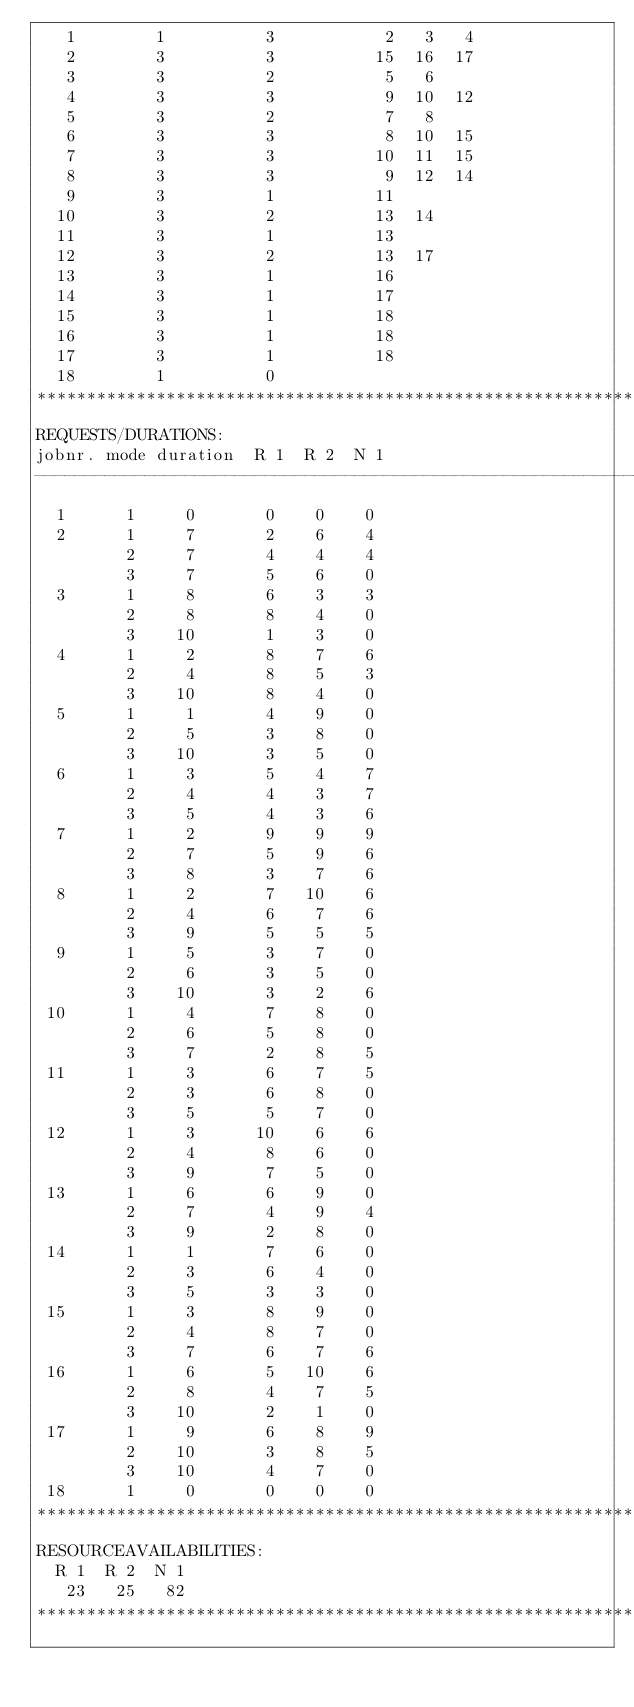<code> <loc_0><loc_0><loc_500><loc_500><_ObjectiveC_>   1        1          3           2   3   4
   2        3          3          15  16  17
   3        3          2           5   6
   4        3          3           9  10  12
   5        3          2           7   8
   6        3          3           8  10  15
   7        3          3          10  11  15
   8        3          3           9  12  14
   9        3          1          11
  10        3          2          13  14
  11        3          1          13
  12        3          2          13  17
  13        3          1          16
  14        3          1          17
  15        3          1          18
  16        3          1          18
  17        3          1          18
  18        1          0        
************************************************************************
REQUESTS/DURATIONS:
jobnr. mode duration  R 1  R 2  N 1
------------------------------------------------------------------------
  1      1     0       0    0    0
  2      1     7       2    6    4
         2     7       4    4    4
         3     7       5    6    0
  3      1     8       6    3    3
         2     8       8    4    0
         3    10       1    3    0
  4      1     2       8    7    6
         2     4       8    5    3
         3    10       8    4    0
  5      1     1       4    9    0
         2     5       3    8    0
         3    10       3    5    0
  6      1     3       5    4    7
         2     4       4    3    7
         3     5       4    3    6
  7      1     2       9    9    9
         2     7       5    9    6
         3     8       3    7    6
  8      1     2       7   10    6
         2     4       6    7    6
         3     9       5    5    5
  9      1     5       3    7    0
         2     6       3    5    0
         3    10       3    2    6
 10      1     4       7    8    0
         2     6       5    8    0
         3     7       2    8    5
 11      1     3       6    7    5
         2     3       6    8    0
         3     5       5    7    0
 12      1     3      10    6    6
         2     4       8    6    0
         3     9       7    5    0
 13      1     6       6    9    0
         2     7       4    9    4
         3     9       2    8    0
 14      1     1       7    6    0
         2     3       6    4    0
         3     5       3    3    0
 15      1     3       8    9    0
         2     4       8    7    0
         3     7       6    7    6
 16      1     6       5   10    6
         2     8       4    7    5
         3    10       2    1    0
 17      1     9       6    8    9
         2    10       3    8    5
         3    10       4    7    0
 18      1     0       0    0    0
************************************************************************
RESOURCEAVAILABILITIES:
  R 1  R 2  N 1
   23   25   82
************************************************************************
</code> 